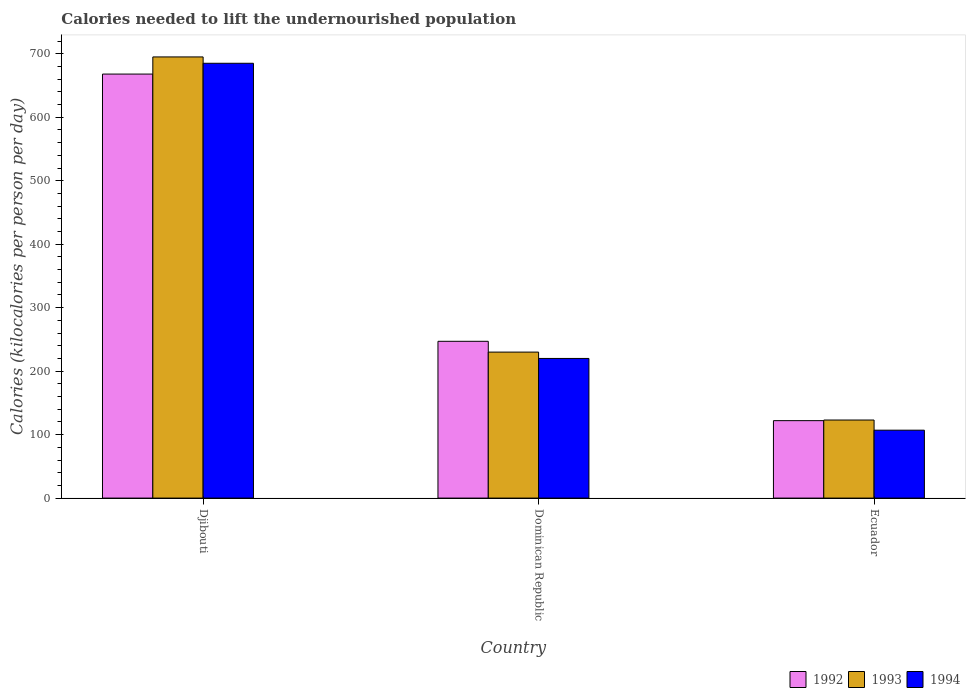How many groups of bars are there?
Offer a terse response. 3. Are the number of bars on each tick of the X-axis equal?
Provide a succinct answer. Yes. How many bars are there on the 1st tick from the left?
Ensure brevity in your answer.  3. What is the label of the 3rd group of bars from the left?
Provide a succinct answer. Ecuador. In how many cases, is the number of bars for a given country not equal to the number of legend labels?
Ensure brevity in your answer.  0. What is the total calories needed to lift the undernourished population in 1994 in Dominican Republic?
Your answer should be compact. 220. Across all countries, what is the maximum total calories needed to lift the undernourished population in 1992?
Ensure brevity in your answer.  668. Across all countries, what is the minimum total calories needed to lift the undernourished population in 1993?
Provide a succinct answer. 123. In which country was the total calories needed to lift the undernourished population in 1993 maximum?
Provide a succinct answer. Djibouti. In which country was the total calories needed to lift the undernourished population in 1992 minimum?
Give a very brief answer. Ecuador. What is the total total calories needed to lift the undernourished population in 1993 in the graph?
Offer a very short reply. 1048. What is the difference between the total calories needed to lift the undernourished population in 1992 in Djibouti and that in Dominican Republic?
Offer a very short reply. 421. What is the difference between the total calories needed to lift the undernourished population in 1993 in Dominican Republic and the total calories needed to lift the undernourished population in 1992 in Djibouti?
Give a very brief answer. -438. What is the average total calories needed to lift the undernourished population in 1992 per country?
Your answer should be compact. 345.67. What is the difference between the total calories needed to lift the undernourished population of/in 1992 and total calories needed to lift the undernourished population of/in 1994 in Djibouti?
Your answer should be very brief. -17. In how many countries, is the total calories needed to lift the undernourished population in 1994 greater than 300 kilocalories?
Offer a terse response. 1. What is the ratio of the total calories needed to lift the undernourished population in 1993 in Djibouti to that in Ecuador?
Give a very brief answer. 5.65. What is the difference between the highest and the second highest total calories needed to lift the undernourished population in 1992?
Make the answer very short. -546. What is the difference between the highest and the lowest total calories needed to lift the undernourished population in 1992?
Provide a short and direct response. 546. Is the sum of the total calories needed to lift the undernourished population in 1993 in Dominican Republic and Ecuador greater than the maximum total calories needed to lift the undernourished population in 1994 across all countries?
Ensure brevity in your answer.  No. Is it the case that in every country, the sum of the total calories needed to lift the undernourished population in 1992 and total calories needed to lift the undernourished population in 1993 is greater than the total calories needed to lift the undernourished population in 1994?
Offer a terse response. Yes. How many bars are there?
Your answer should be compact. 9. How many countries are there in the graph?
Offer a very short reply. 3. Where does the legend appear in the graph?
Provide a short and direct response. Bottom right. How many legend labels are there?
Give a very brief answer. 3. What is the title of the graph?
Offer a very short reply. Calories needed to lift the undernourished population. What is the label or title of the X-axis?
Give a very brief answer. Country. What is the label or title of the Y-axis?
Offer a terse response. Calories (kilocalories per person per day). What is the Calories (kilocalories per person per day) in 1992 in Djibouti?
Keep it short and to the point. 668. What is the Calories (kilocalories per person per day) in 1993 in Djibouti?
Ensure brevity in your answer.  695. What is the Calories (kilocalories per person per day) of 1994 in Djibouti?
Give a very brief answer. 685. What is the Calories (kilocalories per person per day) in 1992 in Dominican Republic?
Offer a very short reply. 247. What is the Calories (kilocalories per person per day) of 1993 in Dominican Republic?
Give a very brief answer. 230. What is the Calories (kilocalories per person per day) in 1994 in Dominican Republic?
Provide a short and direct response. 220. What is the Calories (kilocalories per person per day) of 1992 in Ecuador?
Offer a terse response. 122. What is the Calories (kilocalories per person per day) of 1993 in Ecuador?
Offer a very short reply. 123. What is the Calories (kilocalories per person per day) of 1994 in Ecuador?
Your answer should be very brief. 107. Across all countries, what is the maximum Calories (kilocalories per person per day) of 1992?
Offer a terse response. 668. Across all countries, what is the maximum Calories (kilocalories per person per day) in 1993?
Your response must be concise. 695. Across all countries, what is the maximum Calories (kilocalories per person per day) in 1994?
Your answer should be compact. 685. Across all countries, what is the minimum Calories (kilocalories per person per day) in 1992?
Offer a terse response. 122. Across all countries, what is the minimum Calories (kilocalories per person per day) of 1993?
Your answer should be very brief. 123. Across all countries, what is the minimum Calories (kilocalories per person per day) of 1994?
Your response must be concise. 107. What is the total Calories (kilocalories per person per day) in 1992 in the graph?
Offer a terse response. 1037. What is the total Calories (kilocalories per person per day) of 1993 in the graph?
Ensure brevity in your answer.  1048. What is the total Calories (kilocalories per person per day) of 1994 in the graph?
Ensure brevity in your answer.  1012. What is the difference between the Calories (kilocalories per person per day) in 1992 in Djibouti and that in Dominican Republic?
Ensure brevity in your answer.  421. What is the difference between the Calories (kilocalories per person per day) of 1993 in Djibouti and that in Dominican Republic?
Ensure brevity in your answer.  465. What is the difference between the Calories (kilocalories per person per day) in 1994 in Djibouti and that in Dominican Republic?
Offer a very short reply. 465. What is the difference between the Calories (kilocalories per person per day) in 1992 in Djibouti and that in Ecuador?
Provide a succinct answer. 546. What is the difference between the Calories (kilocalories per person per day) in 1993 in Djibouti and that in Ecuador?
Your response must be concise. 572. What is the difference between the Calories (kilocalories per person per day) of 1994 in Djibouti and that in Ecuador?
Offer a very short reply. 578. What is the difference between the Calories (kilocalories per person per day) in 1992 in Dominican Republic and that in Ecuador?
Offer a terse response. 125. What is the difference between the Calories (kilocalories per person per day) in 1993 in Dominican Republic and that in Ecuador?
Your answer should be compact. 107. What is the difference between the Calories (kilocalories per person per day) of 1994 in Dominican Republic and that in Ecuador?
Your response must be concise. 113. What is the difference between the Calories (kilocalories per person per day) of 1992 in Djibouti and the Calories (kilocalories per person per day) of 1993 in Dominican Republic?
Provide a succinct answer. 438. What is the difference between the Calories (kilocalories per person per day) of 1992 in Djibouti and the Calories (kilocalories per person per day) of 1994 in Dominican Republic?
Your answer should be compact. 448. What is the difference between the Calories (kilocalories per person per day) of 1993 in Djibouti and the Calories (kilocalories per person per day) of 1994 in Dominican Republic?
Provide a short and direct response. 475. What is the difference between the Calories (kilocalories per person per day) in 1992 in Djibouti and the Calories (kilocalories per person per day) in 1993 in Ecuador?
Offer a very short reply. 545. What is the difference between the Calories (kilocalories per person per day) in 1992 in Djibouti and the Calories (kilocalories per person per day) in 1994 in Ecuador?
Your answer should be very brief. 561. What is the difference between the Calories (kilocalories per person per day) in 1993 in Djibouti and the Calories (kilocalories per person per day) in 1994 in Ecuador?
Provide a succinct answer. 588. What is the difference between the Calories (kilocalories per person per day) of 1992 in Dominican Republic and the Calories (kilocalories per person per day) of 1993 in Ecuador?
Ensure brevity in your answer.  124. What is the difference between the Calories (kilocalories per person per day) in 1992 in Dominican Republic and the Calories (kilocalories per person per day) in 1994 in Ecuador?
Provide a short and direct response. 140. What is the difference between the Calories (kilocalories per person per day) in 1993 in Dominican Republic and the Calories (kilocalories per person per day) in 1994 in Ecuador?
Give a very brief answer. 123. What is the average Calories (kilocalories per person per day) in 1992 per country?
Ensure brevity in your answer.  345.67. What is the average Calories (kilocalories per person per day) of 1993 per country?
Your response must be concise. 349.33. What is the average Calories (kilocalories per person per day) in 1994 per country?
Your answer should be very brief. 337.33. What is the difference between the Calories (kilocalories per person per day) in 1992 and Calories (kilocalories per person per day) in 1993 in Djibouti?
Your answer should be very brief. -27. What is the difference between the Calories (kilocalories per person per day) in 1993 and Calories (kilocalories per person per day) in 1994 in Djibouti?
Your response must be concise. 10. What is the difference between the Calories (kilocalories per person per day) of 1992 and Calories (kilocalories per person per day) of 1994 in Dominican Republic?
Give a very brief answer. 27. What is the difference between the Calories (kilocalories per person per day) of 1993 and Calories (kilocalories per person per day) of 1994 in Dominican Republic?
Offer a terse response. 10. What is the ratio of the Calories (kilocalories per person per day) in 1992 in Djibouti to that in Dominican Republic?
Ensure brevity in your answer.  2.7. What is the ratio of the Calories (kilocalories per person per day) of 1993 in Djibouti to that in Dominican Republic?
Your answer should be very brief. 3.02. What is the ratio of the Calories (kilocalories per person per day) in 1994 in Djibouti to that in Dominican Republic?
Provide a succinct answer. 3.11. What is the ratio of the Calories (kilocalories per person per day) in 1992 in Djibouti to that in Ecuador?
Offer a terse response. 5.48. What is the ratio of the Calories (kilocalories per person per day) of 1993 in Djibouti to that in Ecuador?
Your answer should be compact. 5.65. What is the ratio of the Calories (kilocalories per person per day) in 1994 in Djibouti to that in Ecuador?
Your answer should be very brief. 6.4. What is the ratio of the Calories (kilocalories per person per day) in 1992 in Dominican Republic to that in Ecuador?
Provide a short and direct response. 2.02. What is the ratio of the Calories (kilocalories per person per day) of 1993 in Dominican Republic to that in Ecuador?
Provide a succinct answer. 1.87. What is the ratio of the Calories (kilocalories per person per day) in 1994 in Dominican Republic to that in Ecuador?
Offer a very short reply. 2.06. What is the difference between the highest and the second highest Calories (kilocalories per person per day) of 1992?
Give a very brief answer. 421. What is the difference between the highest and the second highest Calories (kilocalories per person per day) in 1993?
Ensure brevity in your answer.  465. What is the difference between the highest and the second highest Calories (kilocalories per person per day) of 1994?
Keep it short and to the point. 465. What is the difference between the highest and the lowest Calories (kilocalories per person per day) of 1992?
Your answer should be compact. 546. What is the difference between the highest and the lowest Calories (kilocalories per person per day) in 1993?
Make the answer very short. 572. What is the difference between the highest and the lowest Calories (kilocalories per person per day) of 1994?
Keep it short and to the point. 578. 